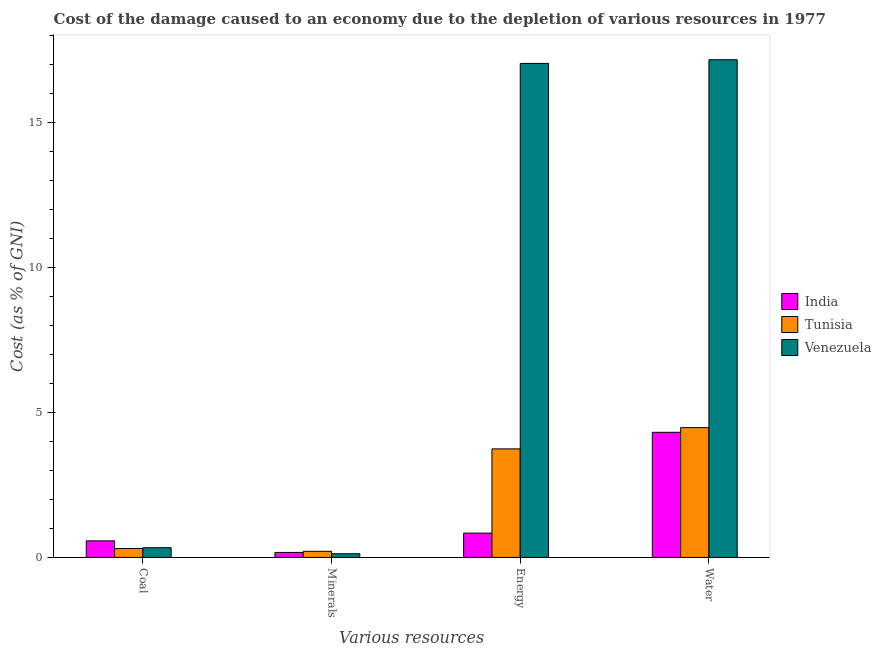How many groups of bars are there?
Give a very brief answer. 4. How many bars are there on the 2nd tick from the left?
Offer a terse response. 3. How many bars are there on the 4th tick from the right?
Provide a short and direct response. 3. What is the label of the 1st group of bars from the left?
Your answer should be very brief. Coal. What is the cost of damage due to depletion of water in India?
Keep it short and to the point. 4.32. Across all countries, what is the maximum cost of damage due to depletion of minerals?
Your response must be concise. 0.21. Across all countries, what is the minimum cost of damage due to depletion of water?
Provide a succinct answer. 4.32. In which country was the cost of damage due to depletion of minerals maximum?
Give a very brief answer. Tunisia. In which country was the cost of damage due to depletion of minerals minimum?
Your answer should be very brief. Venezuela. What is the total cost of damage due to depletion of coal in the graph?
Give a very brief answer. 1.21. What is the difference between the cost of damage due to depletion of energy in India and that in Venezuela?
Ensure brevity in your answer.  -16.2. What is the difference between the cost of damage due to depletion of coal in India and the cost of damage due to depletion of water in Venezuela?
Keep it short and to the point. -16.59. What is the average cost of damage due to depletion of minerals per country?
Your answer should be very brief. 0.17. What is the difference between the cost of damage due to depletion of coal and cost of damage due to depletion of energy in Tunisia?
Offer a very short reply. -3.44. In how many countries, is the cost of damage due to depletion of energy greater than 9 %?
Provide a succinct answer. 1. What is the ratio of the cost of damage due to depletion of coal in India to that in Venezuela?
Provide a succinct answer. 1.7. Is the cost of damage due to depletion of water in Tunisia less than that in Venezuela?
Give a very brief answer. Yes. Is the difference between the cost of damage due to depletion of minerals in India and Tunisia greater than the difference between the cost of damage due to depletion of water in India and Tunisia?
Offer a terse response. Yes. What is the difference between the highest and the second highest cost of damage due to depletion of minerals?
Your answer should be very brief. 0.04. What is the difference between the highest and the lowest cost of damage due to depletion of coal?
Give a very brief answer. 0.26. Is it the case that in every country, the sum of the cost of damage due to depletion of energy and cost of damage due to depletion of coal is greater than the sum of cost of damage due to depletion of minerals and cost of damage due to depletion of water?
Give a very brief answer. No. What does the 1st bar from the right in Coal represents?
Ensure brevity in your answer.  Venezuela. Is it the case that in every country, the sum of the cost of damage due to depletion of coal and cost of damage due to depletion of minerals is greater than the cost of damage due to depletion of energy?
Provide a short and direct response. No. How many countries are there in the graph?
Your response must be concise. 3. Are the values on the major ticks of Y-axis written in scientific E-notation?
Make the answer very short. No. Does the graph contain grids?
Your answer should be compact. No. How are the legend labels stacked?
Offer a very short reply. Vertical. What is the title of the graph?
Give a very brief answer. Cost of the damage caused to an economy due to the depletion of various resources in 1977 . What is the label or title of the X-axis?
Ensure brevity in your answer.  Various resources. What is the label or title of the Y-axis?
Your answer should be very brief. Cost (as % of GNI). What is the Cost (as % of GNI) in India in Coal?
Provide a succinct answer. 0.57. What is the Cost (as % of GNI) of Tunisia in Coal?
Offer a terse response. 0.31. What is the Cost (as % of GNI) of Venezuela in Coal?
Give a very brief answer. 0.34. What is the Cost (as % of GNI) of India in Minerals?
Keep it short and to the point. 0.17. What is the Cost (as % of GNI) of Tunisia in Minerals?
Offer a terse response. 0.21. What is the Cost (as % of GNI) in Venezuela in Minerals?
Your answer should be compact. 0.13. What is the Cost (as % of GNI) of India in Energy?
Ensure brevity in your answer.  0.84. What is the Cost (as % of GNI) in Tunisia in Energy?
Offer a very short reply. 3.74. What is the Cost (as % of GNI) of Venezuela in Energy?
Give a very brief answer. 17.04. What is the Cost (as % of GNI) in India in Water?
Offer a very short reply. 4.32. What is the Cost (as % of GNI) of Tunisia in Water?
Ensure brevity in your answer.  4.48. What is the Cost (as % of GNI) in Venezuela in Water?
Your response must be concise. 17.17. Across all Various resources, what is the maximum Cost (as % of GNI) in India?
Provide a succinct answer. 4.32. Across all Various resources, what is the maximum Cost (as % of GNI) in Tunisia?
Provide a succinct answer. 4.48. Across all Various resources, what is the maximum Cost (as % of GNI) in Venezuela?
Your response must be concise. 17.17. Across all Various resources, what is the minimum Cost (as % of GNI) in India?
Make the answer very short. 0.17. Across all Various resources, what is the minimum Cost (as % of GNI) of Tunisia?
Your answer should be very brief. 0.21. Across all Various resources, what is the minimum Cost (as % of GNI) in Venezuela?
Offer a very short reply. 0.13. What is the total Cost (as % of GNI) of India in the graph?
Offer a terse response. 5.9. What is the total Cost (as % of GNI) in Tunisia in the graph?
Your answer should be compact. 8.74. What is the total Cost (as % of GNI) in Venezuela in the graph?
Provide a succinct answer. 34.67. What is the difference between the Cost (as % of GNI) of India in Coal and that in Minerals?
Provide a short and direct response. 0.4. What is the difference between the Cost (as % of GNI) in Tunisia in Coal and that in Minerals?
Keep it short and to the point. 0.1. What is the difference between the Cost (as % of GNI) in Venezuela in Coal and that in Minerals?
Provide a short and direct response. 0.21. What is the difference between the Cost (as % of GNI) of India in Coal and that in Energy?
Make the answer very short. -0.27. What is the difference between the Cost (as % of GNI) in Tunisia in Coal and that in Energy?
Your response must be concise. -3.44. What is the difference between the Cost (as % of GNI) in Venezuela in Coal and that in Energy?
Your answer should be compact. -16.7. What is the difference between the Cost (as % of GNI) in India in Coal and that in Water?
Make the answer very short. -3.74. What is the difference between the Cost (as % of GNI) in Tunisia in Coal and that in Water?
Provide a short and direct response. -4.17. What is the difference between the Cost (as % of GNI) in Venezuela in Coal and that in Water?
Offer a very short reply. -16.83. What is the difference between the Cost (as % of GNI) in Tunisia in Minerals and that in Energy?
Make the answer very short. -3.53. What is the difference between the Cost (as % of GNI) in Venezuela in Minerals and that in Energy?
Your answer should be very brief. -16.91. What is the difference between the Cost (as % of GNI) of India in Minerals and that in Water?
Your answer should be very brief. -4.14. What is the difference between the Cost (as % of GNI) of Tunisia in Minerals and that in Water?
Offer a very short reply. -4.27. What is the difference between the Cost (as % of GNI) in Venezuela in Minerals and that in Water?
Keep it short and to the point. -17.04. What is the difference between the Cost (as % of GNI) of India in Energy and that in Water?
Make the answer very short. -3.48. What is the difference between the Cost (as % of GNI) of Tunisia in Energy and that in Water?
Ensure brevity in your answer.  -0.73. What is the difference between the Cost (as % of GNI) of Venezuela in Energy and that in Water?
Provide a succinct answer. -0.13. What is the difference between the Cost (as % of GNI) in India in Coal and the Cost (as % of GNI) in Tunisia in Minerals?
Provide a short and direct response. 0.36. What is the difference between the Cost (as % of GNI) of India in Coal and the Cost (as % of GNI) of Venezuela in Minerals?
Provide a short and direct response. 0.45. What is the difference between the Cost (as % of GNI) of Tunisia in Coal and the Cost (as % of GNI) of Venezuela in Minerals?
Keep it short and to the point. 0.18. What is the difference between the Cost (as % of GNI) of India in Coal and the Cost (as % of GNI) of Tunisia in Energy?
Give a very brief answer. -3.17. What is the difference between the Cost (as % of GNI) of India in Coal and the Cost (as % of GNI) of Venezuela in Energy?
Your answer should be very brief. -16.47. What is the difference between the Cost (as % of GNI) of Tunisia in Coal and the Cost (as % of GNI) of Venezuela in Energy?
Keep it short and to the point. -16.73. What is the difference between the Cost (as % of GNI) of India in Coal and the Cost (as % of GNI) of Tunisia in Water?
Make the answer very short. -3.9. What is the difference between the Cost (as % of GNI) in India in Coal and the Cost (as % of GNI) in Venezuela in Water?
Offer a very short reply. -16.59. What is the difference between the Cost (as % of GNI) in Tunisia in Coal and the Cost (as % of GNI) in Venezuela in Water?
Ensure brevity in your answer.  -16.86. What is the difference between the Cost (as % of GNI) of India in Minerals and the Cost (as % of GNI) of Tunisia in Energy?
Keep it short and to the point. -3.57. What is the difference between the Cost (as % of GNI) in India in Minerals and the Cost (as % of GNI) in Venezuela in Energy?
Your response must be concise. -16.87. What is the difference between the Cost (as % of GNI) in Tunisia in Minerals and the Cost (as % of GNI) in Venezuela in Energy?
Provide a succinct answer. -16.83. What is the difference between the Cost (as % of GNI) in India in Minerals and the Cost (as % of GNI) in Tunisia in Water?
Your answer should be very brief. -4.3. What is the difference between the Cost (as % of GNI) in India in Minerals and the Cost (as % of GNI) in Venezuela in Water?
Your answer should be compact. -16.99. What is the difference between the Cost (as % of GNI) in Tunisia in Minerals and the Cost (as % of GNI) in Venezuela in Water?
Make the answer very short. -16.95. What is the difference between the Cost (as % of GNI) of India in Energy and the Cost (as % of GNI) of Tunisia in Water?
Ensure brevity in your answer.  -3.64. What is the difference between the Cost (as % of GNI) in India in Energy and the Cost (as % of GNI) in Venezuela in Water?
Provide a short and direct response. -16.33. What is the difference between the Cost (as % of GNI) in Tunisia in Energy and the Cost (as % of GNI) in Venezuela in Water?
Your answer should be very brief. -13.42. What is the average Cost (as % of GNI) of India per Various resources?
Your response must be concise. 1.47. What is the average Cost (as % of GNI) of Tunisia per Various resources?
Provide a short and direct response. 2.18. What is the average Cost (as % of GNI) in Venezuela per Various resources?
Your response must be concise. 8.67. What is the difference between the Cost (as % of GNI) of India and Cost (as % of GNI) of Tunisia in Coal?
Ensure brevity in your answer.  0.26. What is the difference between the Cost (as % of GNI) of India and Cost (as % of GNI) of Venezuela in Coal?
Ensure brevity in your answer.  0.24. What is the difference between the Cost (as % of GNI) of Tunisia and Cost (as % of GNI) of Venezuela in Coal?
Offer a terse response. -0.03. What is the difference between the Cost (as % of GNI) in India and Cost (as % of GNI) in Tunisia in Minerals?
Provide a short and direct response. -0.04. What is the difference between the Cost (as % of GNI) in India and Cost (as % of GNI) in Venezuela in Minerals?
Ensure brevity in your answer.  0.05. What is the difference between the Cost (as % of GNI) of Tunisia and Cost (as % of GNI) of Venezuela in Minerals?
Give a very brief answer. 0.08. What is the difference between the Cost (as % of GNI) of India and Cost (as % of GNI) of Tunisia in Energy?
Offer a very short reply. -2.91. What is the difference between the Cost (as % of GNI) in India and Cost (as % of GNI) in Venezuela in Energy?
Make the answer very short. -16.2. What is the difference between the Cost (as % of GNI) of Tunisia and Cost (as % of GNI) of Venezuela in Energy?
Keep it short and to the point. -13.29. What is the difference between the Cost (as % of GNI) of India and Cost (as % of GNI) of Tunisia in Water?
Your answer should be very brief. -0.16. What is the difference between the Cost (as % of GNI) of India and Cost (as % of GNI) of Venezuela in Water?
Make the answer very short. -12.85. What is the difference between the Cost (as % of GNI) in Tunisia and Cost (as % of GNI) in Venezuela in Water?
Make the answer very short. -12.69. What is the ratio of the Cost (as % of GNI) of India in Coal to that in Minerals?
Give a very brief answer. 3.32. What is the ratio of the Cost (as % of GNI) of Tunisia in Coal to that in Minerals?
Keep it short and to the point. 1.46. What is the ratio of the Cost (as % of GNI) in Venezuela in Coal to that in Minerals?
Keep it short and to the point. 2.65. What is the ratio of the Cost (as % of GNI) in India in Coal to that in Energy?
Give a very brief answer. 0.68. What is the ratio of the Cost (as % of GNI) of Tunisia in Coal to that in Energy?
Make the answer very short. 0.08. What is the ratio of the Cost (as % of GNI) of Venezuela in Coal to that in Energy?
Keep it short and to the point. 0.02. What is the ratio of the Cost (as % of GNI) of India in Coal to that in Water?
Your response must be concise. 0.13. What is the ratio of the Cost (as % of GNI) in Tunisia in Coal to that in Water?
Offer a terse response. 0.07. What is the ratio of the Cost (as % of GNI) in Venezuela in Coal to that in Water?
Your response must be concise. 0.02. What is the ratio of the Cost (as % of GNI) in India in Minerals to that in Energy?
Provide a short and direct response. 0.21. What is the ratio of the Cost (as % of GNI) in Tunisia in Minerals to that in Energy?
Offer a terse response. 0.06. What is the ratio of the Cost (as % of GNI) of Venezuela in Minerals to that in Energy?
Offer a very short reply. 0.01. What is the ratio of the Cost (as % of GNI) in India in Minerals to that in Water?
Offer a very short reply. 0.04. What is the ratio of the Cost (as % of GNI) in Tunisia in Minerals to that in Water?
Provide a short and direct response. 0.05. What is the ratio of the Cost (as % of GNI) of Venezuela in Minerals to that in Water?
Provide a succinct answer. 0.01. What is the ratio of the Cost (as % of GNI) in India in Energy to that in Water?
Your answer should be compact. 0.19. What is the ratio of the Cost (as % of GNI) of Tunisia in Energy to that in Water?
Make the answer very short. 0.84. What is the difference between the highest and the second highest Cost (as % of GNI) in India?
Your answer should be very brief. 3.48. What is the difference between the highest and the second highest Cost (as % of GNI) in Tunisia?
Your response must be concise. 0.73. What is the difference between the highest and the second highest Cost (as % of GNI) in Venezuela?
Make the answer very short. 0.13. What is the difference between the highest and the lowest Cost (as % of GNI) of India?
Keep it short and to the point. 4.14. What is the difference between the highest and the lowest Cost (as % of GNI) in Tunisia?
Provide a short and direct response. 4.27. What is the difference between the highest and the lowest Cost (as % of GNI) in Venezuela?
Ensure brevity in your answer.  17.04. 